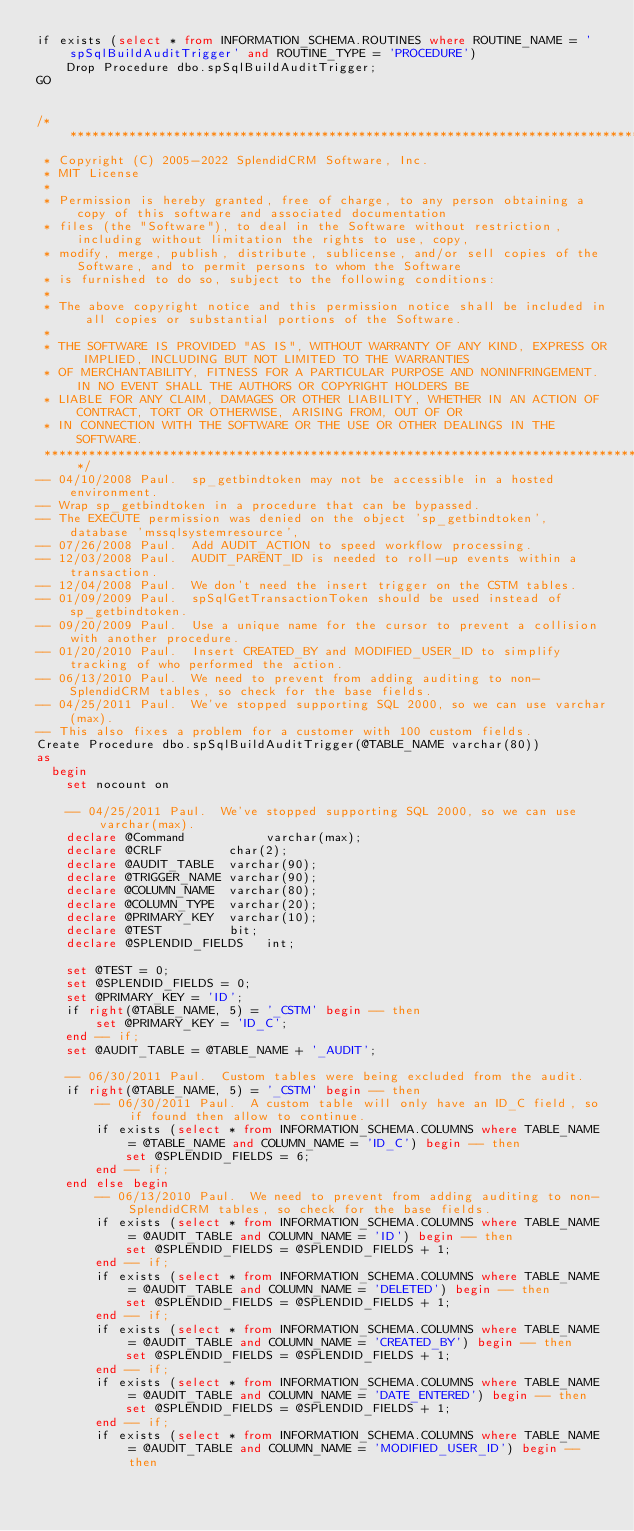<code> <loc_0><loc_0><loc_500><loc_500><_SQL_>if exists (select * from INFORMATION_SCHEMA.ROUTINES where ROUTINE_NAME = 'spSqlBuildAuditTrigger' and ROUTINE_TYPE = 'PROCEDURE')
	Drop Procedure dbo.spSqlBuildAuditTrigger;
GO


/**********************************************************************************************************************
 * Copyright (C) 2005-2022 SplendidCRM Software, Inc. 
 * MIT License
 * 
 * Permission is hereby granted, free of charge, to any person obtaining a copy of this software and associated documentation 
 * files (the "Software"), to deal in the Software without restriction, including without limitation the rights to use, copy, 
 * modify, merge, publish, distribute, sublicense, and/or sell copies of the Software, and to permit persons to whom the Software 
 * is furnished to do so, subject to the following conditions:
 * 
 * The above copyright notice and this permission notice shall be included in all copies or substantial portions of the Software.
 * 
 * THE SOFTWARE IS PROVIDED "AS IS", WITHOUT WARRANTY OF ANY KIND, EXPRESS OR IMPLIED, INCLUDING BUT NOT LIMITED TO THE WARRANTIES 
 * OF MERCHANTABILITY, FITNESS FOR A PARTICULAR PURPOSE AND NONINFRINGEMENT. IN NO EVENT SHALL THE AUTHORS OR COPYRIGHT HOLDERS BE 
 * LIABLE FOR ANY CLAIM, DAMAGES OR OTHER LIABILITY, WHETHER IN AN ACTION OF CONTRACT, TORT OR OTHERWISE, ARISING FROM, OUT OF OR 
 * IN CONNECTION WITH THE SOFTWARE OR THE USE OR OTHER DEALINGS IN THE SOFTWARE.
 *********************************************************************************************************************/
-- 04/10/2008 Paul.  sp_getbindtoken may not be accessible in a hosted environment. 
-- Wrap sp_getbindtoken in a procedure that can be bypassed.
-- The EXECUTE permission was denied on the object 'sp_getbindtoken', database 'mssqlsystemresource', 
-- 07/26/2008 Paul.  Add AUDIT_ACTION to speed workflow processing. 
-- 12/03/2008 Paul.  AUDIT_PARENT_ID is needed to roll-up events within a transaction. 
-- 12/04/2008 Paul.  We don't need the insert trigger on the CSTM tables. 
-- 01/09/2009 Paul.  spSqlGetTransactionToken should be used instead of sp_getbindtoken. 
-- 09/20/2009 Paul.  Use a unique name for the cursor to prevent a collision with another procedure. 
-- 01/20/2010 Paul.  Insert CREATED_BY and MODIFIED_USER_ID to simplify tracking of who performed the action. 
-- 06/13/2010 Paul.  We need to prevent from adding auditing to non-SplendidCRM tables, so check for the base fields. 
-- 04/25/2011 Paul.  We've stopped supporting SQL 2000, so we can use varchar(max). 
-- This also fixes a problem for a customer with 100 custom fields. 
Create Procedure dbo.spSqlBuildAuditTrigger(@TABLE_NAME varchar(80))
as
  begin
	set nocount on
	
	-- 04/25/2011 Paul.  We've stopped supporting SQL 2000, so we can use varchar(max). 
	declare @Command           varchar(max);
	declare @CRLF         char(2);
	declare @AUDIT_TABLE  varchar(90);
	declare @TRIGGER_NAME varchar(90);
	declare @COLUMN_NAME  varchar(80);
	declare @COLUMN_TYPE  varchar(20);
	declare @PRIMARY_KEY  varchar(10);
	declare @TEST         bit;
	declare @SPLENDID_FIELDS   int;

	set @TEST = 0;
	set @SPLENDID_FIELDS = 0;
	set @PRIMARY_KEY = 'ID';
	if right(@TABLE_NAME, 5) = '_CSTM' begin -- then
		set @PRIMARY_KEY = 'ID_C';
	end -- if;
	set @AUDIT_TABLE = @TABLE_NAME + '_AUDIT';

	-- 06/30/2011 Paul.  Custom tables were being excluded from the audit. 
	if right(@TABLE_NAME, 5) = '_CSTM' begin -- then
		-- 06/30/2011 Paul.  A custom table will only have an ID_C field, so if found then allow to continue. 
		if exists (select * from INFORMATION_SCHEMA.COLUMNS where TABLE_NAME = @TABLE_NAME and COLUMN_NAME = 'ID_C') begin -- then
			set @SPLENDID_FIELDS = 6;
		end -- if;
	end else begin
		-- 06/13/2010 Paul.  We need to prevent from adding auditing to non-SplendidCRM tables, so check for the base fields. 
		if exists (select * from INFORMATION_SCHEMA.COLUMNS where TABLE_NAME = @AUDIT_TABLE and COLUMN_NAME = 'ID') begin -- then
			set @SPLENDID_FIELDS = @SPLENDID_FIELDS + 1;
		end -- if;
		if exists (select * from INFORMATION_SCHEMA.COLUMNS where TABLE_NAME = @AUDIT_TABLE and COLUMN_NAME = 'DELETED') begin -- then
			set @SPLENDID_FIELDS = @SPLENDID_FIELDS + 1;
		end -- if;
		if exists (select * from INFORMATION_SCHEMA.COLUMNS where TABLE_NAME = @AUDIT_TABLE and COLUMN_NAME = 'CREATED_BY') begin -- then
			set @SPLENDID_FIELDS = @SPLENDID_FIELDS + 1;
		end -- if;
		if exists (select * from INFORMATION_SCHEMA.COLUMNS where TABLE_NAME = @AUDIT_TABLE and COLUMN_NAME = 'DATE_ENTERED') begin -- then
			set @SPLENDID_FIELDS = @SPLENDID_FIELDS + 1;
		end -- if;
		if exists (select * from INFORMATION_SCHEMA.COLUMNS where TABLE_NAME = @AUDIT_TABLE and COLUMN_NAME = 'MODIFIED_USER_ID') begin -- then</code> 